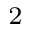Convert formula to latex. <formula><loc_0><loc_0><loc_500><loc_500>^ { 2 }</formula> 